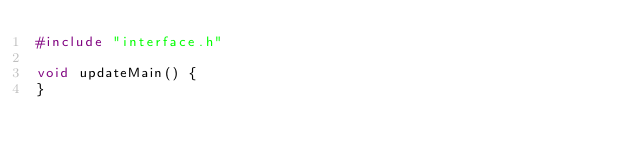<code> <loc_0><loc_0><loc_500><loc_500><_C++_>#include "interface.h"

void updateMain() {
}
</code> 